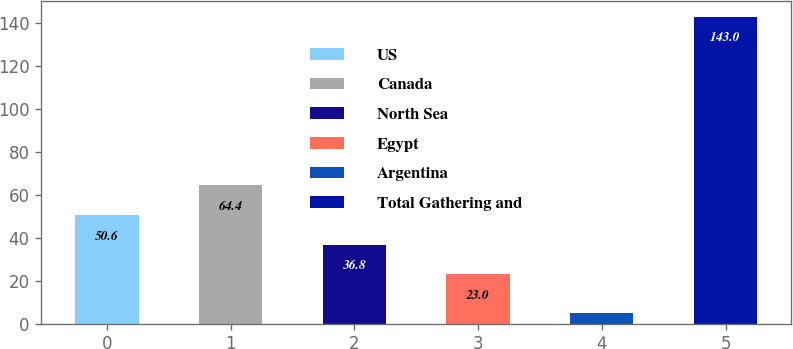Convert chart. <chart><loc_0><loc_0><loc_500><loc_500><bar_chart><fcel>US<fcel>Canada<fcel>North Sea<fcel>Egypt<fcel>Argentina<fcel>Total Gathering and<nl><fcel>50.6<fcel>64.4<fcel>36.8<fcel>23<fcel>5<fcel>143<nl></chart> 